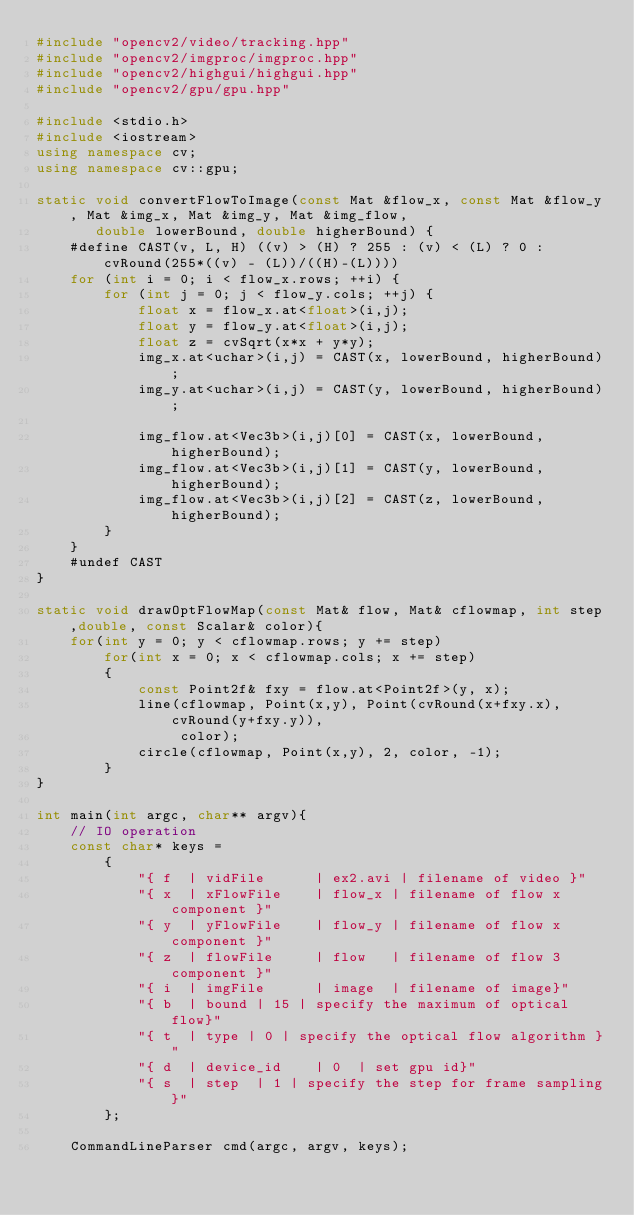Convert code to text. <code><loc_0><loc_0><loc_500><loc_500><_C++_>#include "opencv2/video/tracking.hpp"
#include "opencv2/imgproc/imgproc.hpp"
#include "opencv2/highgui/highgui.hpp"
#include "opencv2/gpu/gpu.hpp"

#include <stdio.h>
#include <iostream>
using namespace cv;
using namespace cv::gpu;

static void convertFlowToImage(const Mat &flow_x, const Mat &flow_y, Mat &img_x, Mat &img_y, Mat &img_flow,
       double lowerBound, double higherBound) {
	#define CAST(v, L, H) ((v) > (H) ? 255 : (v) < (L) ? 0 : cvRound(255*((v) - (L))/((H)-(L))))
	for (int i = 0; i < flow_x.rows; ++i) {
		for (int j = 0; j < flow_y.cols; ++j) {
			float x = flow_x.at<float>(i,j);
			float y = flow_y.at<float>(i,j);
            float z = cvSqrt(x*x + y*y);
			img_x.at<uchar>(i,j) = CAST(x, lowerBound, higherBound);
			img_y.at<uchar>(i,j) = CAST(y, lowerBound, higherBound);

            img_flow.at<Vec3b>(i,j)[0] = CAST(x, lowerBound, higherBound);
            img_flow.at<Vec3b>(i,j)[1] = CAST(y, lowerBound, higherBound);
            img_flow.at<Vec3b>(i,j)[2] = CAST(z, lowerBound, higherBound);
		}
	}
	#undef CAST
}

static void drawOptFlowMap(const Mat& flow, Mat& cflowmap, int step,double, const Scalar& color){
    for(int y = 0; y < cflowmap.rows; y += step)
        for(int x = 0; x < cflowmap.cols; x += step)
        {
            const Point2f& fxy = flow.at<Point2f>(y, x);
            line(cflowmap, Point(x,y), Point(cvRound(x+fxy.x), cvRound(y+fxy.y)),
                 color);
            circle(cflowmap, Point(x,y), 2, color, -1);
        }
}

int main(int argc, char** argv){
	// IO operation
	const char* keys =
		{
			"{ f  | vidFile      | ex2.avi | filename of video }"
			"{ x  | xFlowFile    | flow_x | filename of flow x component }"
			"{ y  | yFlowFile    | flow_y | filename of flow x component }"
            "{ z  | flowFile     | flow   | filename of flow 3 component }"
			"{ i  | imgFile      | image  | filename of image}"
			"{ b  | bound | 15 | specify the maximum of optical flow}"
			"{ t  | type | 0 | specify the optical flow algorithm }"
			"{ d  | device_id    | 0  | set gpu id}"
			"{ s  | step  | 1 | specify the step for frame sampling}"
		};

	CommandLineParser cmd(argc, argv, keys);</code> 